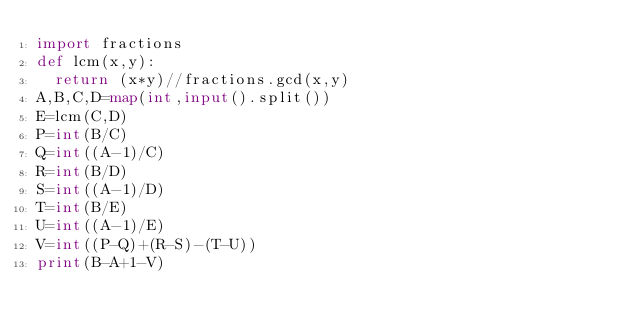Convert code to text. <code><loc_0><loc_0><loc_500><loc_500><_Python_>import fractions
def lcm(x,y):
	return (x*y)//fractions.gcd(x,y)
A,B,C,D=map(int,input().split())
E=lcm(C,D)
P=int(B/C)
Q=int((A-1)/C)
R=int(B/D)
S=int((A-1)/D)
T=int(B/E)
U=int((A-1)/E)
V=int((P-Q)+(R-S)-(T-U))
print(B-A+1-V)</code> 